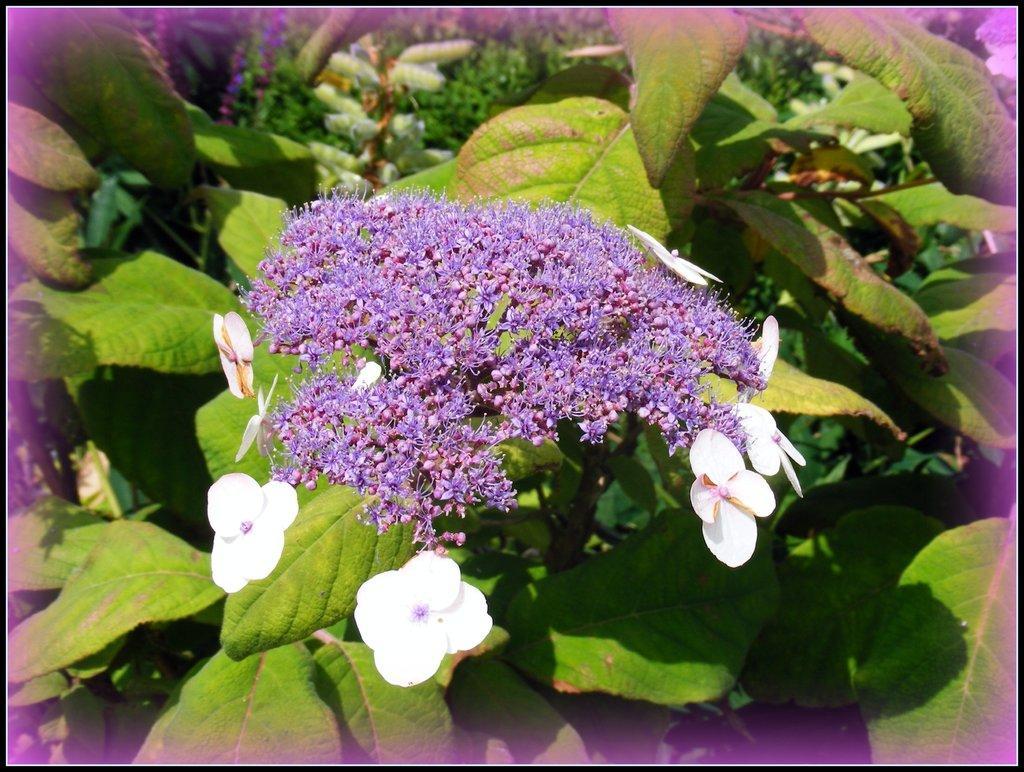Describe this image in one or two sentences. In this image we can see group of flowers and some leaves. 